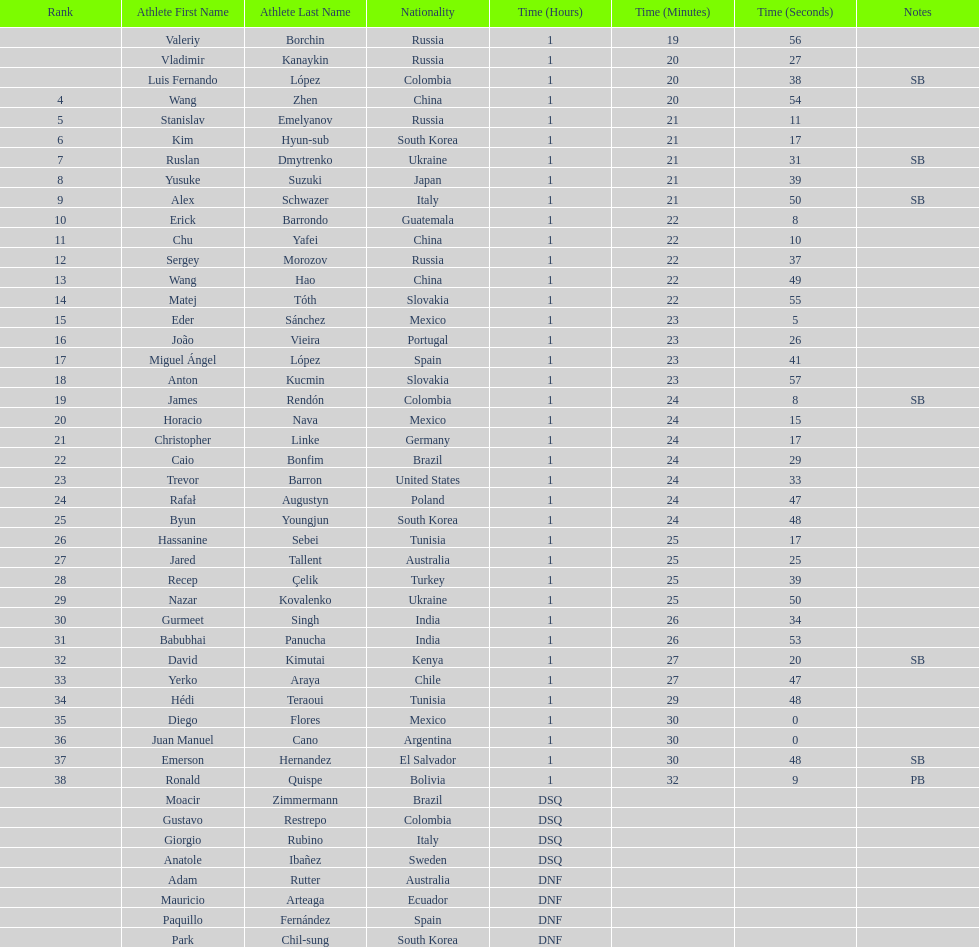Who placed in the top spot? Valeriy Borchin. 